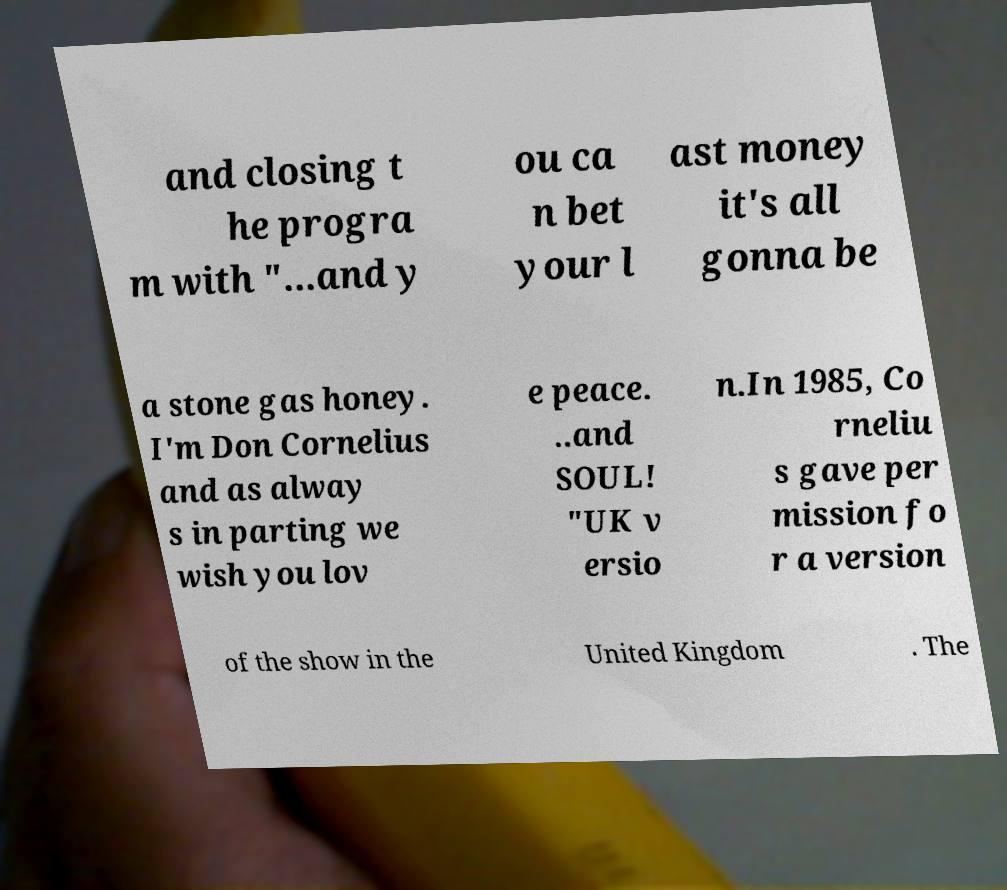Could you assist in decoding the text presented in this image and type it out clearly? and closing t he progra m with "...and y ou ca n bet your l ast money it's all gonna be a stone gas honey. I'm Don Cornelius and as alway s in parting we wish you lov e peace. ..and SOUL! "UK v ersio n.In 1985, Co rneliu s gave per mission fo r a version of the show in the United Kingdom . The 